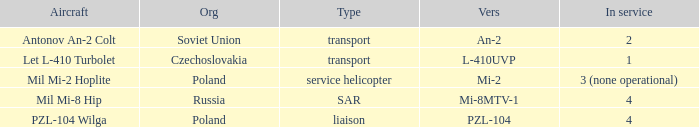Could you parse the entire table as a dict? {'header': ['Aircraft', 'Org', 'Type', 'Vers', 'In service'], 'rows': [['Antonov An-2 Colt', 'Soviet Union', 'transport', 'An-2', '2'], ['Let L-410 Turbolet', 'Czechoslovakia', 'transport', 'L-410UVP', '1'], ['Mil Mi-2 Hoplite', 'Poland', 'service helicopter', 'Mi-2', '3 (none operational)'], ['Mil Mi-8 Hip', 'Russia', 'SAR', 'Mi-8MTV-1', '4'], ['PZL-104 Wilga', 'Poland', 'liaison', 'PZL-104', '4']]} Tell me the versions for czechoslovakia? L-410UVP. 